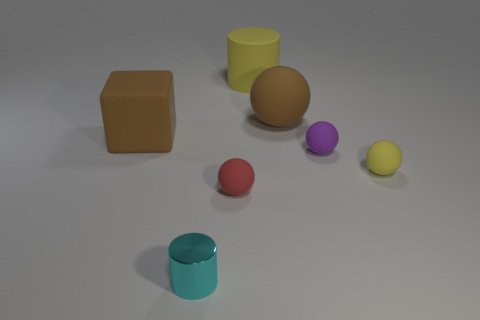Does the yellow cylinder have the same material as the small yellow thing?
Give a very brief answer. Yes. Is the number of metallic objects that are to the left of the tiny yellow matte sphere the same as the number of big cyan metal blocks?
Your answer should be very brief. No. How many small spheres have the same material as the large sphere?
Offer a terse response. 3. Are there fewer large yellow rubber things than small green spheres?
Provide a succinct answer. No. Do the large rubber object that is left of the metallic thing and the metallic thing have the same color?
Provide a short and direct response. No. There is a large thing on the left side of the matte cylinder to the right of the red matte ball; how many small purple things are right of it?
Provide a short and direct response. 1. How many big matte blocks are left of the large brown block?
Provide a succinct answer. 0. There is another big thing that is the same shape as the purple matte thing; what color is it?
Your answer should be very brief. Brown. There is a tiny object that is both left of the big rubber cylinder and behind the cyan cylinder; what material is it?
Offer a terse response. Rubber. There is a yellow thing that is on the right side of the yellow cylinder; does it have the same size as the cyan shiny thing?
Ensure brevity in your answer.  Yes. 